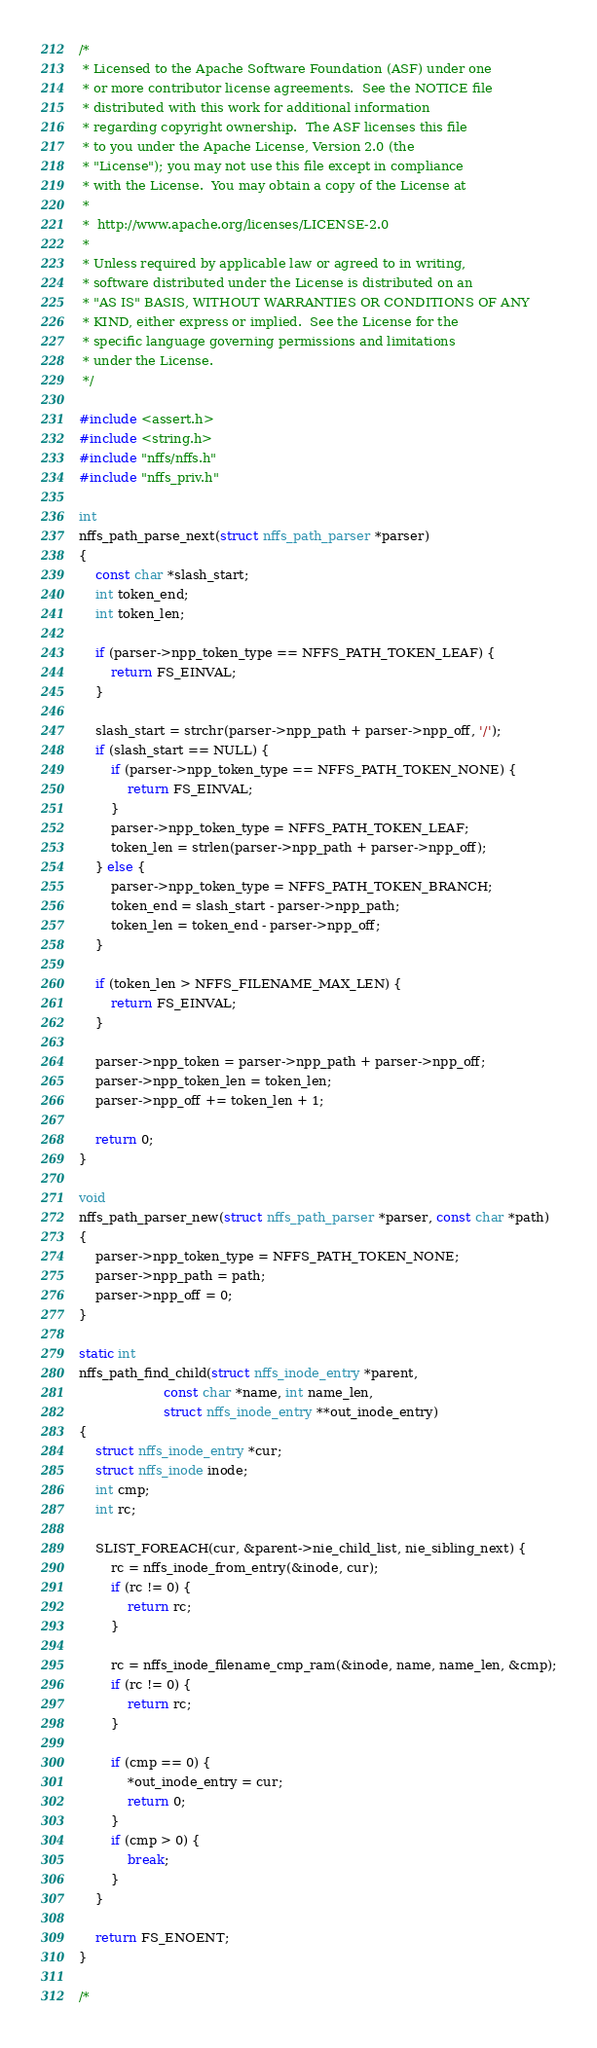Convert code to text. <code><loc_0><loc_0><loc_500><loc_500><_C_>/*
 * Licensed to the Apache Software Foundation (ASF) under one
 * or more contributor license agreements.  See the NOTICE file
 * distributed with this work for additional information
 * regarding copyright ownership.  The ASF licenses this file
 * to you under the Apache License, Version 2.0 (the
 * "License"); you may not use this file except in compliance
 * with the License.  You may obtain a copy of the License at
 * 
 *  http://www.apache.org/licenses/LICENSE-2.0
 *
 * Unless required by applicable law or agreed to in writing,
 * software distributed under the License is distributed on an
 * "AS IS" BASIS, WITHOUT WARRANTIES OR CONDITIONS OF ANY
 * KIND, either express or implied.  See the License for the
 * specific language governing permissions and limitations
 * under the License.
 */

#include <assert.h>
#include <string.h>
#include "nffs/nffs.h"
#include "nffs_priv.h"

int
nffs_path_parse_next(struct nffs_path_parser *parser)
{
    const char *slash_start;
    int token_end;
    int token_len;

    if (parser->npp_token_type == NFFS_PATH_TOKEN_LEAF) {
        return FS_EINVAL;
    }

    slash_start = strchr(parser->npp_path + parser->npp_off, '/');
    if (slash_start == NULL) {
        if (parser->npp_token_type == NFFS_PATH_TOKEN_NONE) {
            return FS_EINVAL;
        }
        parser->npp_token_type = NFFS_PATH_TOKEN_LEAF;
        token_len = strlen(parser->npp_path + parser->npp_off);
    } else {
        parser->npp_token_type = NFFS_PATH_TOKEN_BRANCH;
        token_end = slash_start - parser->npp_path;
        token_len = token_end - parser->npp_off;
    }

    if (token_len > NFFS_FILENAME_MAX_LEN) {
        return FS_EINVAL;
    }

    parser->npp_token = parser->npp_path + parser->npp_off;
    parser->npp_token_len = token_len;
    parser->npp_off += token_len + 1;

    return 0;
}

void
nffs_path_parser_new(struct nffs_path_parser *parser, const char *path)
{
    parser->npp_token_type = NFFS_PATH_TOKEN_NONE;
    parser->npp_path = path;
    parser->npp_off = 0;
}

static int
nffs_path_find_child(struct nffs_inode_entry *parent,
                     const char *name, int name_len,
                     struct nffs_inode_entry **out_inode_entry)
{
    struct nffs_inode_entry *cur;
    struct nffs_inode inode;
    int cmp;
    int rc;

    SLIST_FOREACH(cur, &parent->nie_child_list, nie_sibling_next) {
        rc = nffs_inode_from_entry(&inode, cur);
        if (rc != 0) {
            return rc;
        }

        rc = nffs_inode_filename_cmp_ram(&inode, name, name_len, &cmp);
        if (rc != 0) {
            return rc;
        }

        if (cmp == 0) {
            *out_inode_entry = cur;
            return 0;
        }
        if (cmp > 0) {
            break;
        }
    }

    return FS_ENOENT;
}

/*</code> 